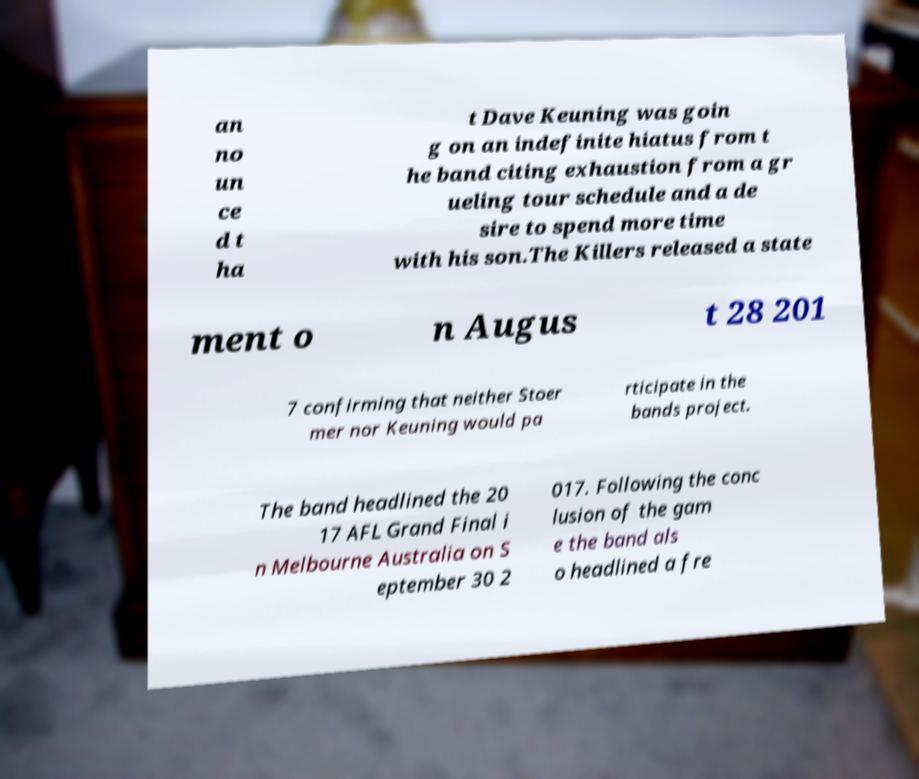Could you extract and type out the text from this image? an no un ce d t ha t Dave Keuning was goin g on an indefinite hiatus from t he band citing exhaustion from a gr ueling tour schedule and a de sire to spend more time with his son.The Killers released a state ment o n Augus t 28 201 7 confirming that neither Stoer mer nor Keuning would pa rticipate in the bands project. The band headlined the 20 17 AFL Grand Final i n Melbourne Australia on S eptember 30 2 017. Following the conc lusion of the gam e the band als o headlined a fre 